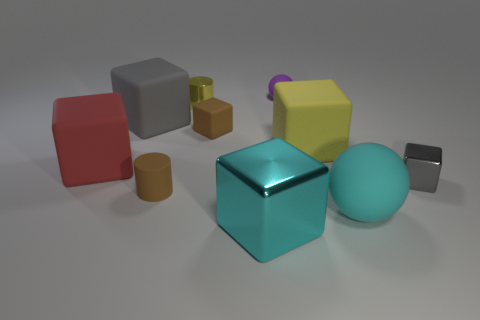Subtract all metal cubes. How many cubes are left? 4 Subtract 1 cubes. How many cubes are left? 5 Subtract all gray cubes. How many cubes are left? 4 Subtract all green cylinders. How many gray cubes are left? 2 Subtract all blocks. How many objects are left? 4 Subtract all blue balls. Subtract all brown blocks. How many balls are left? 2 Subtract all yellow cubes. Subtract all tiny metallic cubes. How many objects are left? 8 Add 7 small brown rubber cylinders. How many small brown rubber cylinders are left? 8 Add 1 metal cylinders. How many metal cylinders exist? 2 Subtract 0 gray spheres. How many objects are left? 10 